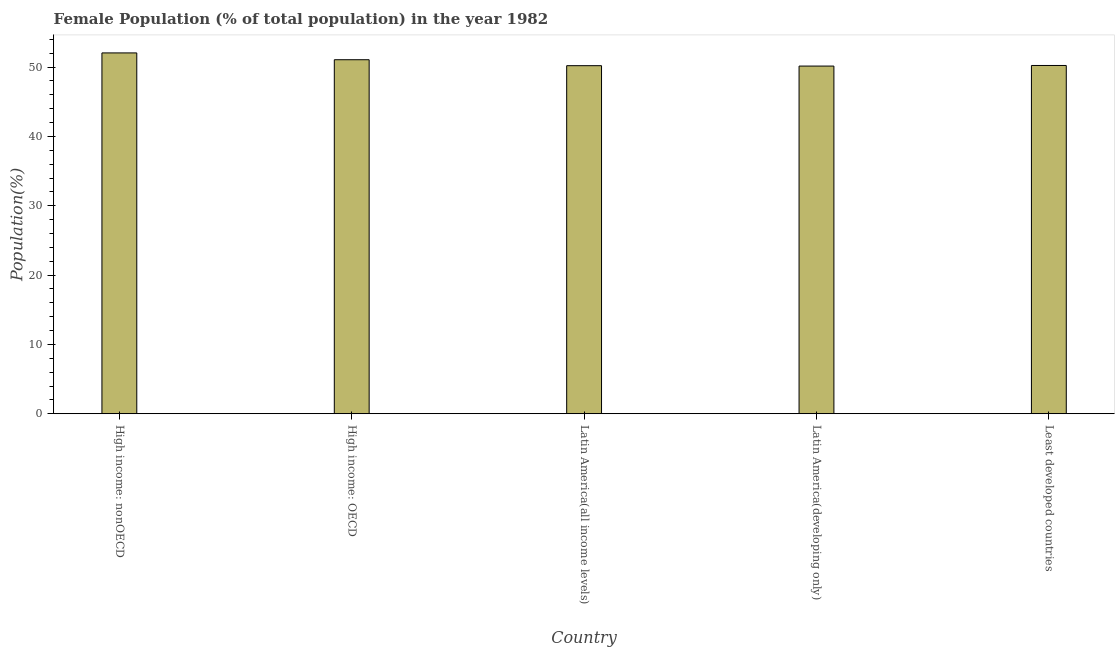What is the title of the graph?
Offer a terse response. Female Population (% of total population) in the year 1982. What is the label or title of the X-axis?
Provide a short and direct response. Country. What is the label or title of the Y-axis?
Your response must be concise. Population(%). What is the female population in High income: nonOECD?
Provide a succinct answer. 52.05. Across all countries, what is the maximum female population?
Keep it short and to the point. 52.05. Across all countries, what is the minimum female population?
Your answer should be compact. 50.15. In which country was the female population maximum?
Keep it short and to the point. High income: nonOECD. In which country was the female population minimum?
Ensure brevity in your answer.  Latin America(developing only). What is the sum of the female population?
Keep it short and to the point. 253.72. What is the difference between the female population in High income: OECD and Latin America(developing only)?
Give a very brief answer. 0.92. What is the average female population per country?
Your answer should be compact. 50.74. What is the median female population?
Your answer should be compact. 50.24. What is the ratio of the female population in Latin America(all income levels) to that in Least developed countries?
Keep it short and to the point. 1. Is the female population in High income: OECD less than that in High income: nonOECD?
Your answer should be very brief. Yes. Is the difference between the female population in High income: nonOECD and Least developed countries greater than the difference between any two countries?
Your answer should be compact. No. Is the sum of the female population in Latin America(all income levels) and Latin America(developing only) greater than the maximum female population across all countries?
Keep it short and to the point. Yes. What is the difference between the highest and the lowest female population?
Offer a terse response. 1.9. How many bars are there?
Offer a very short reply. 5. Are all the bars in the graph horizontal?
Your answer should be very brief. No. How many countries are there in the graph?
Your answer should be very brief. 5. What is the difference between two consecutive major ticks on the Y-axis?
Offer a terse response. 10. Are the values on the major ticks of Y-axis written in scientific E-notation?
Make the answer very short. No. What is the Population(%) in High income: nonOECD?
Ensure brevity in your answer.  52.05. What is the Population(%) in High income: OECD?
Provide a short and direct response. 51.07. What is the Population(%) in Latin America(all income levels)?
Give a very brief answer. 50.21. What is the Population(%) in Latin America(developing only)?
Provide a succinct answer. 50.15. What is the Population(%) of Least developed countries?
Ensure brevity in your answer.  50.24. What is the difference between the Population(%) in High income: nonOECD and High income: OECD?
Make the answer very short. 0.98. What is the difference between the Population(%) in High income: nonOECD and Latin America(all income levels)?
Offer a terse response. 1.84. What is the difference between the Population(%) in High income: nonOECD and Latin America(developing only)?
Offer a very short reply. 1.9. What is the difference between the Population(%) in High income: nonOECD and Least developed countries?
Give a very brief answer. 1.81. What is the difference between the Population(%) in High income: OECD and Latin America(all income levels)?
Provide a succinct answer. 0.86. What is the difference between the Population(%) in High income: OECD and Latin America(developing only)?
Your answer should be compact. 0.91. What is the difference between the Population(%) in High income: OECD and Least developed countries?
Make the answer very short. 0.83. What is the difference between the Population(%) in Latin America(all income levels) and Latin America(developing only)?
Your response must be concise. 0.06. What is the difference between the Population(%) in Latin America(all income levels) and Least developed countries?
Offer a terse response. -0.03. What is the difference between the Population(%) in Latin America(developing only) and Least developed countries?
Give a very brief answer. -0.09. What is the ratio of the Population(%) in High income: nonOECD to that in High income: OECD?
Keep it short and to the point. 1.02. What is the ratio of the Population(%) in High income: nonOECD to that in Latin America(developing only)?
Offer a very short reply. 1.04. What is the ratio of the Population(%) in High income: nonOECD to that in Least developed countries?
Provide a succinct answer. 1.04. What is the ratio of the Population(%) in High income: OECD to that in Latin America(all income levels)?
Give a very brief answer. 1.02. What is the ratio of the Population(%) in High income: OECD to that in Latin America(developing only)?
Your answer should be very brief. 1.02. What is the ratio of the Population(%) in High income: OECD to that in Least developed countries?
Ensure brevity in your answer.  1.02. What is the ratio of the Population(%) in Latin America(all income levels) to that in Latin America(developing only)?
Offer a very short reply. 1. What is the ratio of the Population(%) in Latin America(developing only) to that in Least developed countries?
Provide a short and direct response. 1. 